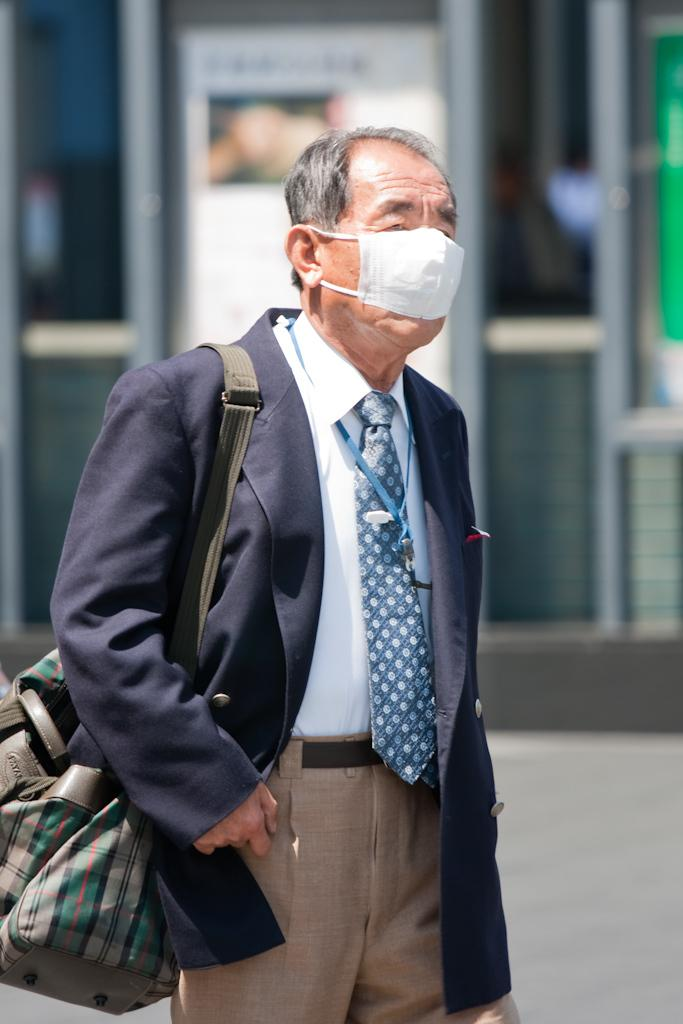Who is present in the image? There is a man in the image. What is the man wearing? The man is wearing a suit and a mask. What is the man carrying in the image? The man is carrying a bag. Can you describe the background of the image? The background of the image is blurred. What type of snake can be seen in the argument between the man and the woman in the image? There is no snake or woman present in the image; it only features a man wearing a suit, a mask, and carrying a bag. 